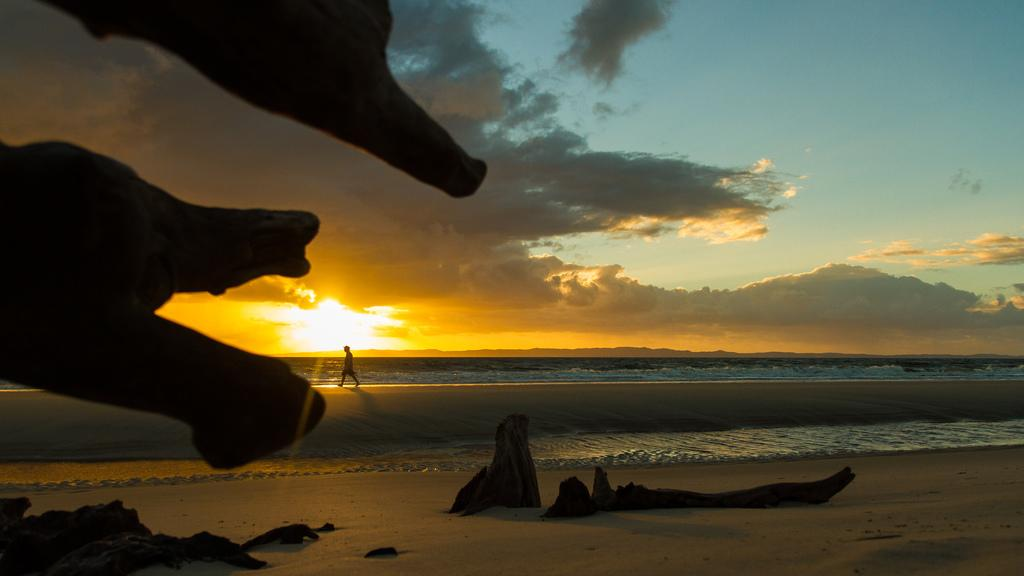What is located in the middle of the picture? There is driftwood in the middle of the picture. Who or what can be seen on the left side of the picture? There is a person on the left side of the picture. What is visible in the background of the picture? There is an ocean and clouds in the sky in the background of the picture. Can you see any rabbits in the picture? There are no rabbits present in the image. What type of insect is flying near the person in the picture? There is no insect visible in the image. 